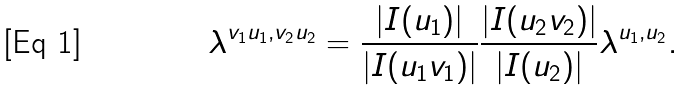Convert formula to latex. <formula><loc_0><loc_0><loc_500><loc_500>\lambda ^ { v _ { 1 } u _ { 1 } , v _ { 2 } u _ { 2 } } = \frac { | I ( u _ { 1 } ) | } { | I ( u _ { 1 } v _ { 1 } ) | } \frac { | I ( u _ { 2 } v _ { 2 } ) | } { | I ( u _ { 2 } ) | } \lambda ^ { u _ { 1 } , u _ { 2 } } .</formula> 